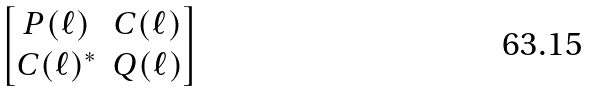Convert formula to latex. <formula><loc_0><loc_0><loc_500><loc_500>\begin{bmatrix} P ( \ell ) & C ( \ell ) \\ C ( \ell ) ^ { * } & Q ( \ell ) \end{bmatrix}</formula> 